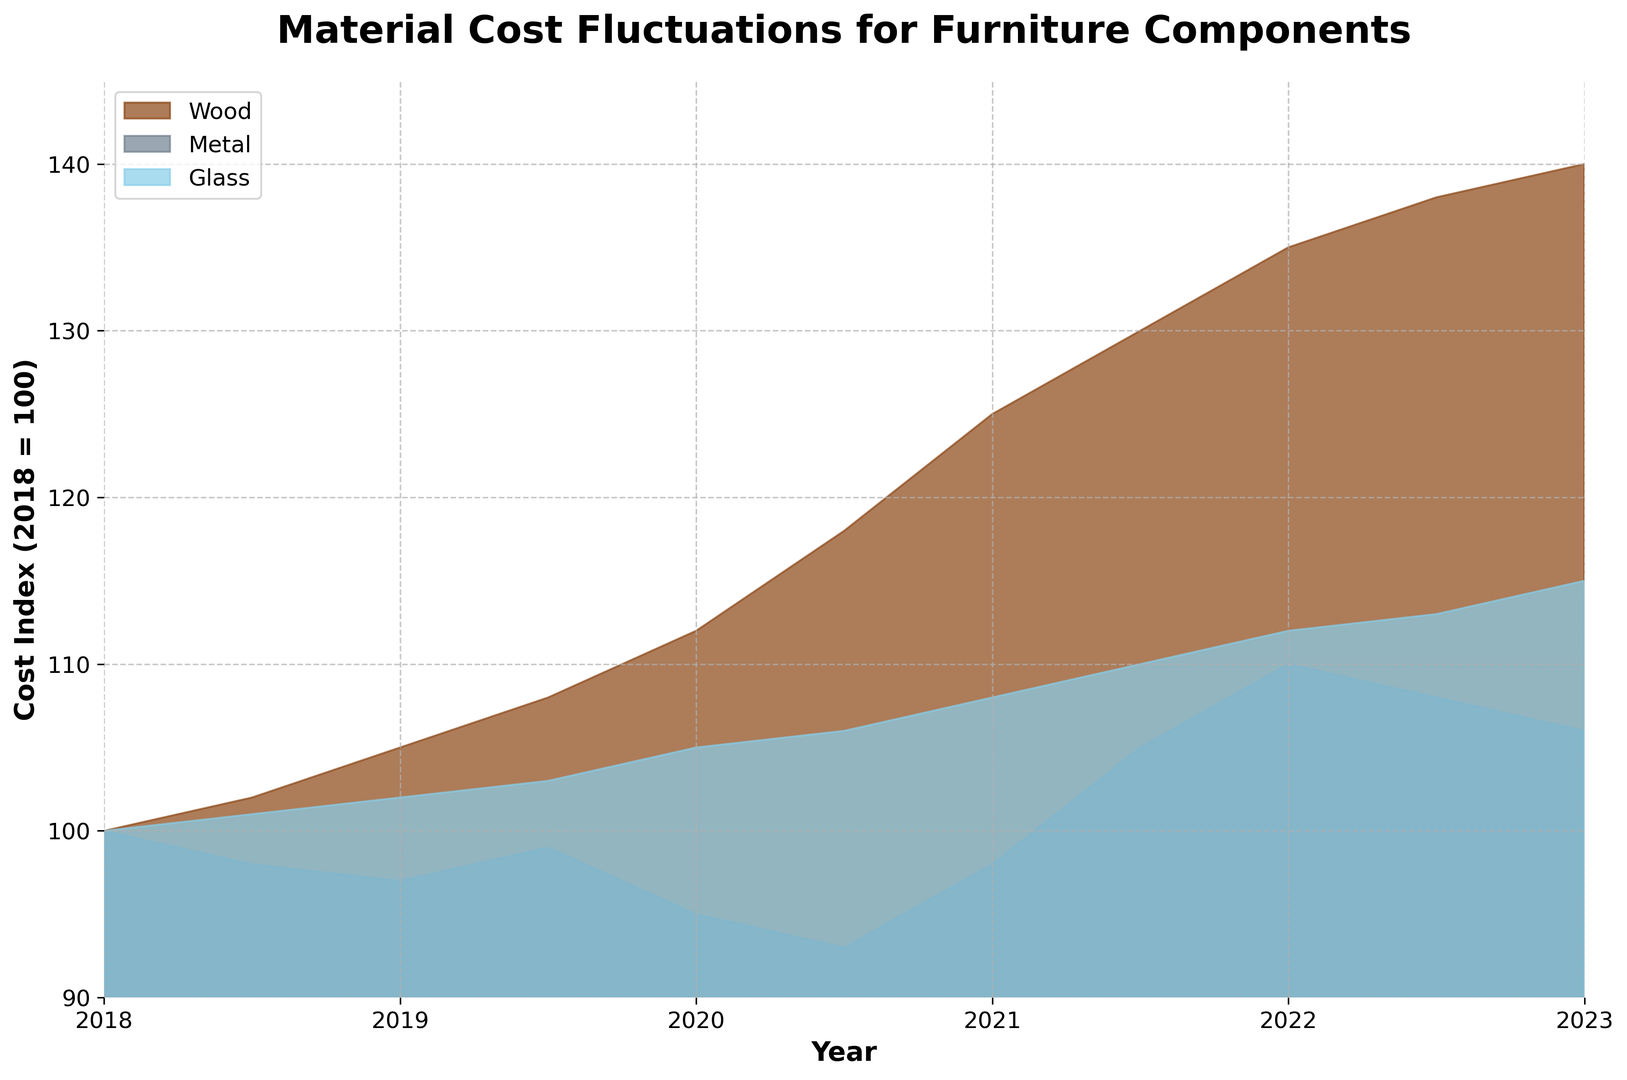What year did Wood's cost index surpass 130? The plot shows the cost index for wood, metal, and glass over the years. Follow the curve representing wood and find the point where it first goes above 130. This happens around mid-2021.
Answer: 2021.5 Between 2021 and 2023, which material shows a decrease in its cost index? Examine the curves for each material between 2021 and 2023. Both wood and glass show an increasing trend, while metal displays a slight decrease towards the end of the period.
Answer: Metal Compare the cost indices of Wood and Metal in 2020. Which one was more expensive? Look at the cost indices on the y-axis for the year 2020. The wood curve is higher than the metal curve, indicating that wood was more expensive in 2020.
Answer: Wood Which material had the most significant cost increase from 2018 to 2023? Compare the height of the curves for all materials from 2018 to 2023. Wood increased from 100 to 140, metal decreased slightly, and glass increased from 100 to 115. Wood had the most significant increase.
Answer: Wood By how much did the cost index of Glass increase from 2020.5 to 2022.5? Note the cost index for glass at 2020.5 (106) and 2022.5 (113). The increase is calculated by subtracting 106 from 113.
Answer: 7 Which year witnessed the highest cost index for Metal? Follow the curve for metal and identify the highest point. The highest value for metal is around 2022, with a value of 110.
Answer: 2022 Is there any period when the cost index for Metal was consistently decreasing? Examine the metal cost index curve for any segment where it continuously drops. From 2018 to mid-2020, the metal cost index generally decreases.
Answer: 2018 to 2020 Does the cost index of Glass ever exceed 115? Check the peak value of the glass curve to see if it goes beyond 115. It reaches precisely 115 in 2023 but does not exceed it.
Answer: No 